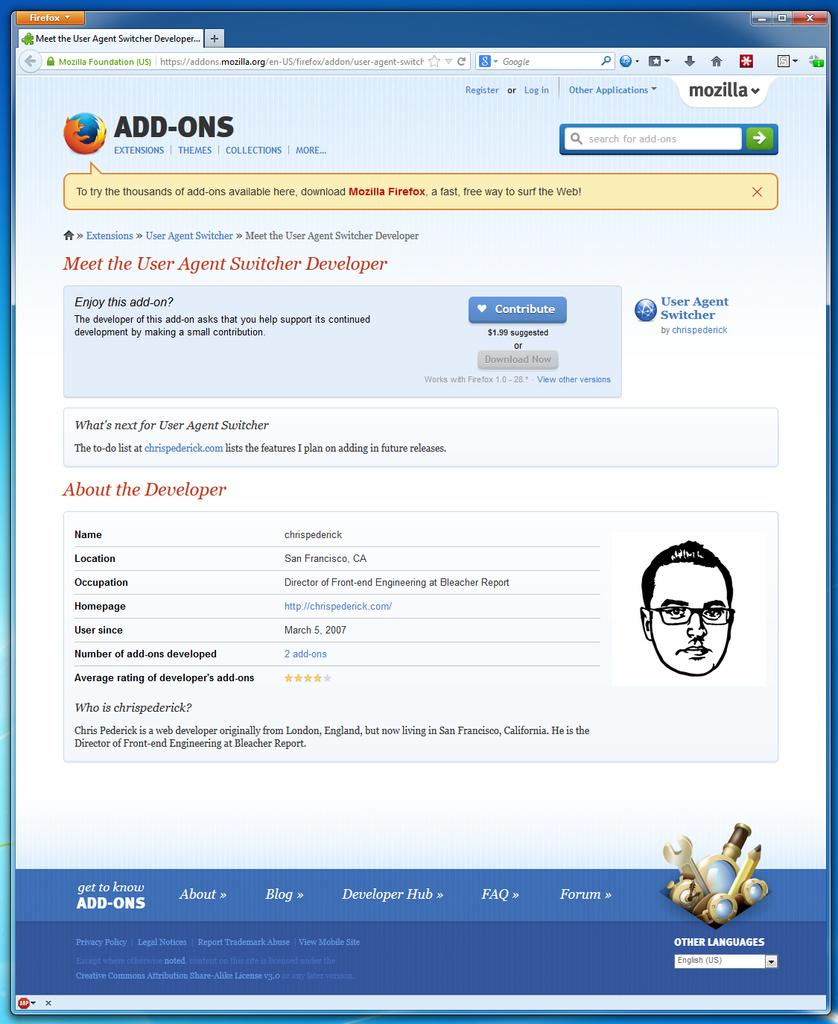What is the main subject of the image? The main subject of the image is a picture of a computer screen. Can you describe what is displayed on the computer screen? Unfortunately, the specific content of the computer screen cannot be determined from the image alone. What type of hat is the machine wearing in the image? There is no machine or hat present in the image; it only features a picture of a computer screen. 